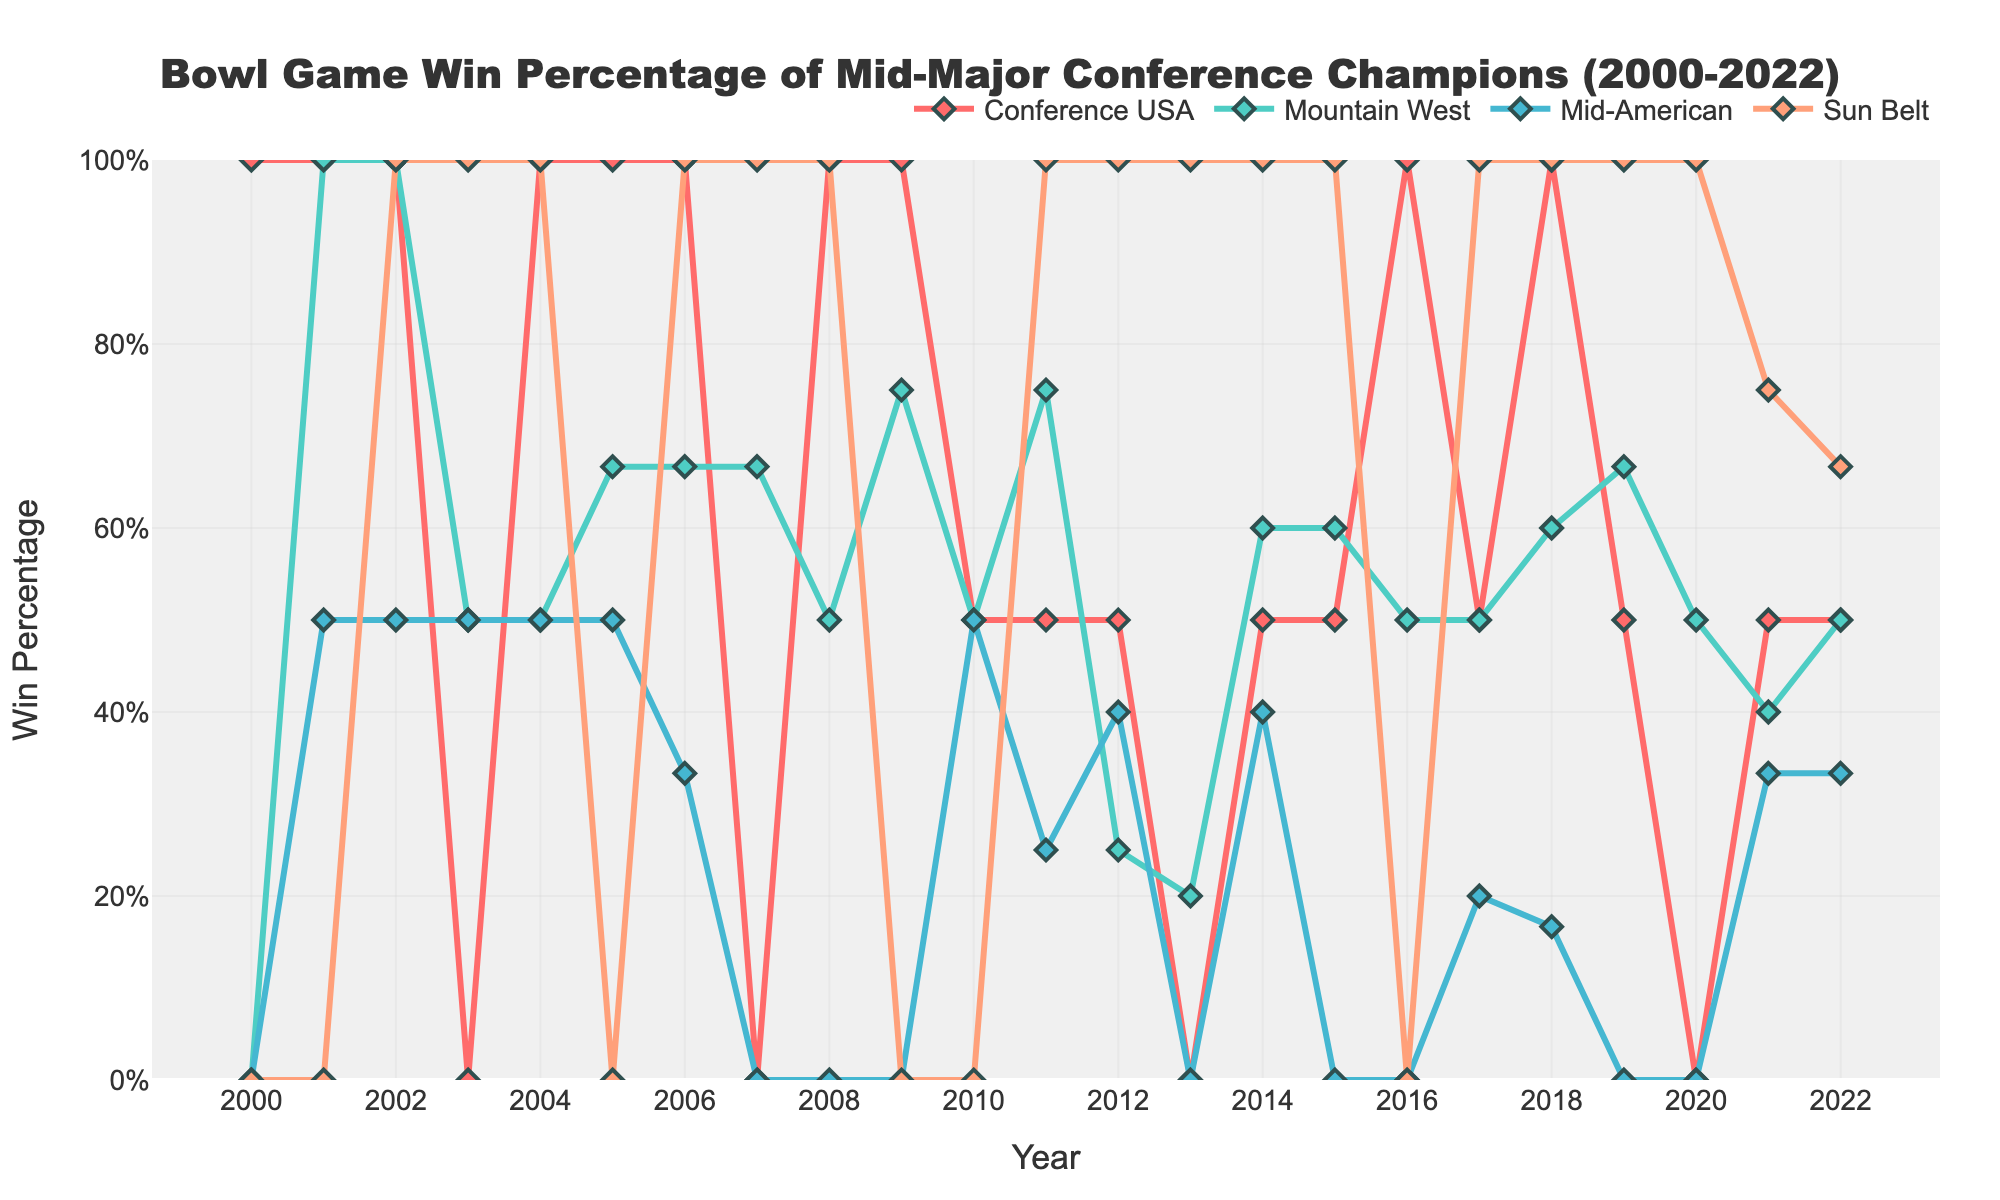What year did the Conference USA champions achieve their highest win percentage? Observe the line graph for Conference USA and locate the peak point indicating the highest win percentage. The highest win percentage for Conference USA is in 2009 with 2 wins and 0 losses, resulting in a 100% win rate.
Answer: 2009 Which conference had the highest win percentage in 2016? Compare the points for each conference in 2016. Conference USA and Sun Belt both have a win percentage of 100% (2-0 and 0-1 converted to 2-0 for Sun Belt), but Conference USA has the highest with more games played.
Answer: Conference USA In which year did the Mid-American conference champions have their lowest win percentage? Identify the year where the Mid-American conference line touches the bottom for the lowest win percentage. The lowest win percentage (0%) occurs when they have 0 wins, which happens in 2008, 2013, 2015, 2016, and 2019, hence considering first appearance in 2008.
Answer: 2008 How many times did Mountain West champions achieve over 50% win percentage? Count the number of points above the 50% threshold on the Mountain West line. The years are 2002, 2005, 2006, 2007, 2009, 2011, 2014, 2015, 2016, 2017, 2018, 2019 and 2022.
Answer: 13 Which conference showed the most consistency in win percentage over the years? Assess the overall variance and fluctuations in the line representing each conference. Sun Belt shows the most consistency, maintaining high win percentages frequently with fewer fluctuations compared to others.
Answer: Sun Belt 